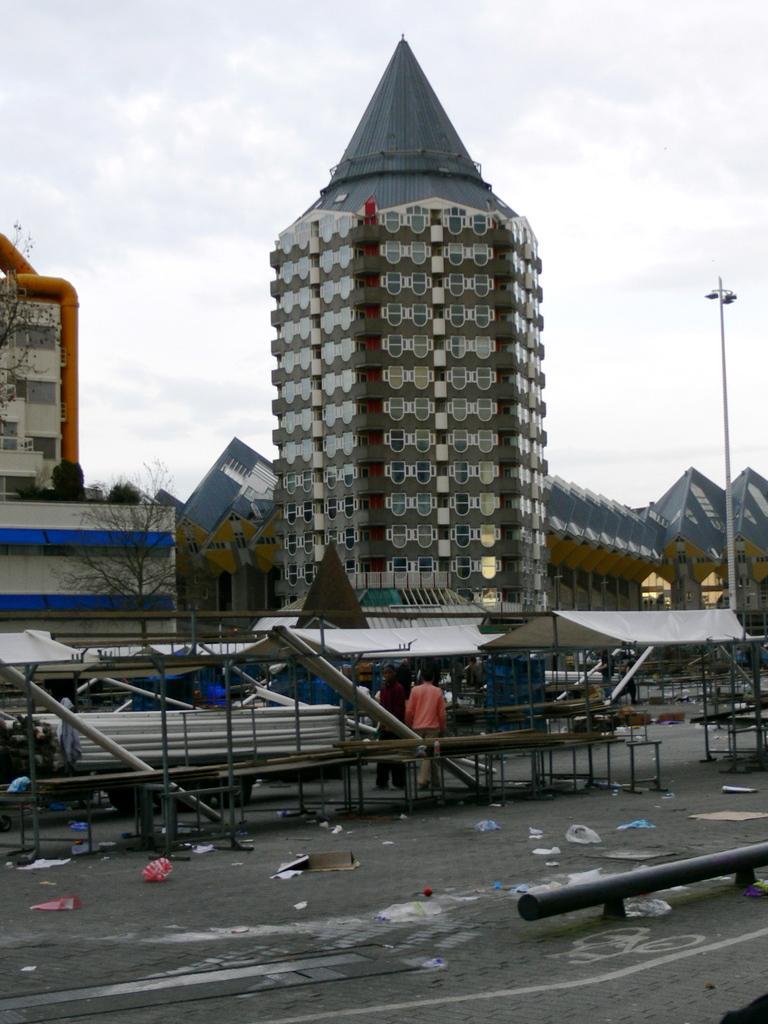Can you describe this image briefly? These are the buildings with windows. This looks like a street light. I can see two people standing. This is the tree with branches. These look like benches. I can see covers, papers and few other things lying on the ground. This looks like an iron pipe. 